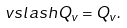Convert formula to latex. <formula><loc_0><loc_0><loc_500><loc_500>\ v s l a s h Q _ { v } = Q _ { v } .</formula> 